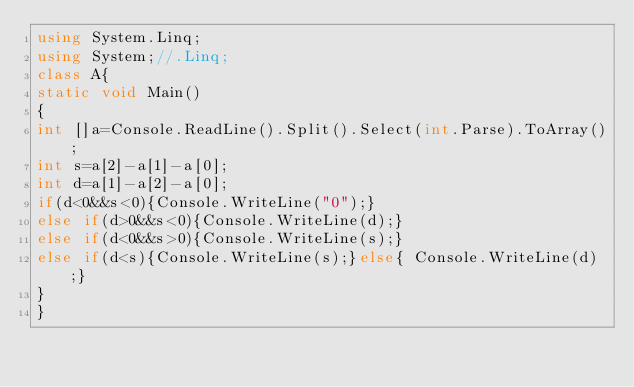Convert code to text. <code><loc_0><loc_0><loc_500><loc_500><_C#_>using System.Linq;
using System;//.Linq;
class A{
static void Main()
{
int []a=Console.ReadLine().Split().Select(int.Parse).ToArray();
int s=a[2]-a[1]-a[0];
int d=a[1]-a[2]-a[0];
if(d<0&&s<0){Console.WriteLine("0");}
else if(d>0&&s<0){Console.WriteLine(d);}
else if(d<0&&s>0){Console.WriteLine(s);}
else if(d<s){Console.WriteLine(s);}else{ Console.WriteLine(d);}
}
}</code> 